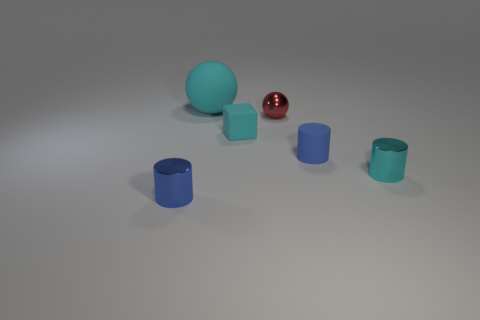Are there fewer blue metal things than large purple objects?
Make the answer very short. No. Does the tiny blue thing that is in front of the small rubber cylinder have the same material as the sphere right of the big cyan matte object?
Your answer should be compact. Yes. Is the number of large rubber objects in front of the small blue matte cylinder less than the number of large rubber balls?
Provide a succinct answer. Yes. There is a cylinder that is right of the small matte cylinder; how many matte balls are to the right of it?
Ensure brevity in your answer.  0. What is the size of the cyan thing that is on the left side of the cyan cylinder and in front of the big matte ball?
Give a very brief answer. Small. Is there anything else that has the same material as the small red ball?
Your response must be concise. Yes. Do the tiny cyan cylinder and the tiny thing that is behind the small cube have the same material?
Give a very brief answer. Yes. Are there fewer small blue matte objects left of the red shiny ball than big cyan rubber spheres behind the blue matte thing?
Ensure brevity in your answer.  Yes. What is the material of the big cyan object behind the small blue shiny thing?
Your response must be concise. Rubber. There is a thing that is both on the left side of the tiny red thing and on the right side of the large cyan rubber sphere; what is its color?
Your answer should be compact. Cyan. 